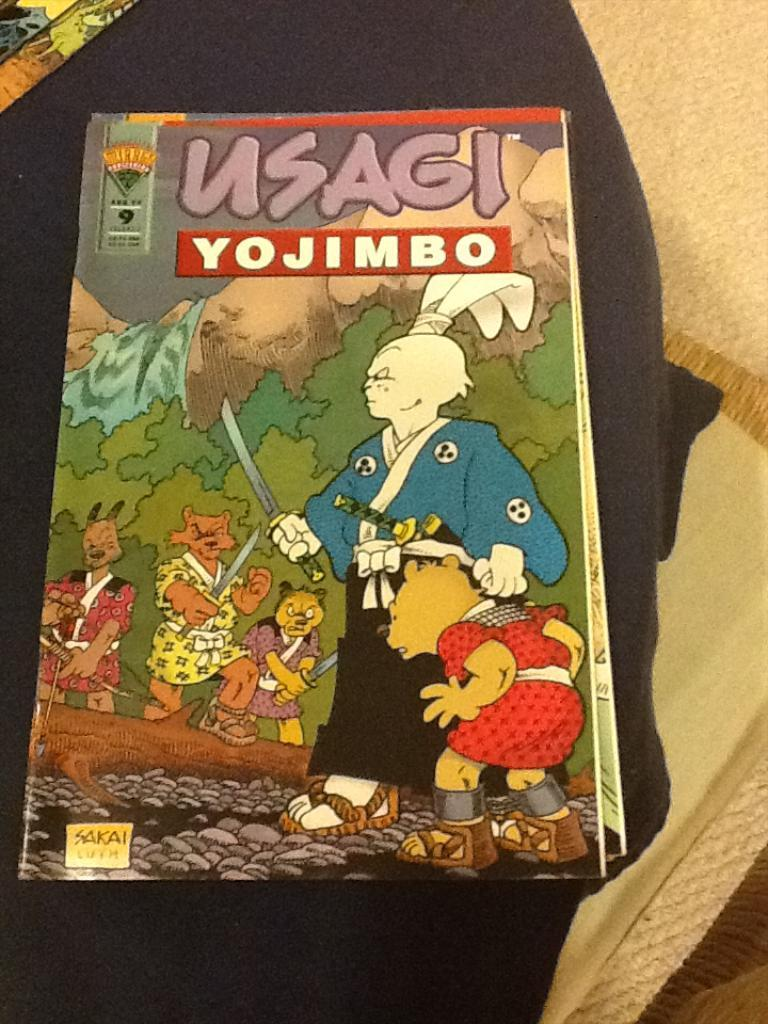<image>
Write a terse but informative summary of the picture. An anime comic book that is called Usagi Yojimbo 